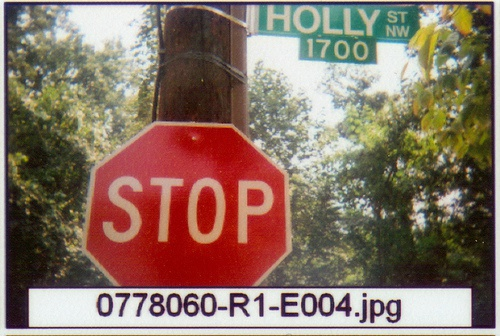Describe the objects in this image and their specific colors. I can see a stop sign in white, brown, and tan tones in this image. 